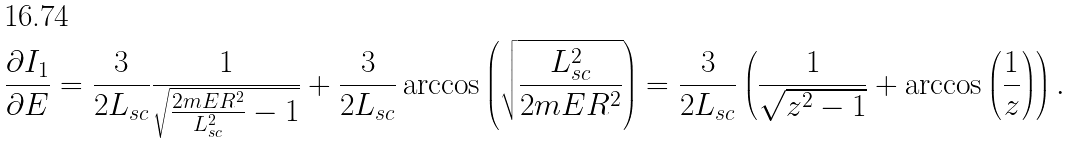Convert formula to latex. <formula><loc_0><loc_0><loc_500><loc_500>\frac { \partial I _ { 1 } } { \partial E } = \frac { 3 } { 2 L _ { s c } } \frac { 1 } { \sqrt { \frac { 2 m E R ^ { 2 } } { L _ { s c } ^ { 2 } } - 1 } } + \frac { 3 } { 2 L _ { s c } } \arccos \left ( \sqrt { \frac { L ^ { 2 } _ { s c } } { 2 m E R ^ { 2 } } } \right ) = \frac { 3 } { 2 L _ { s c } } \left ( \frac { 1 } { \sqrt { z ^ { 2 } - 1 } } + \arccos \left ( \frac { 1 } { z } \right ) \right ) .</formula> 